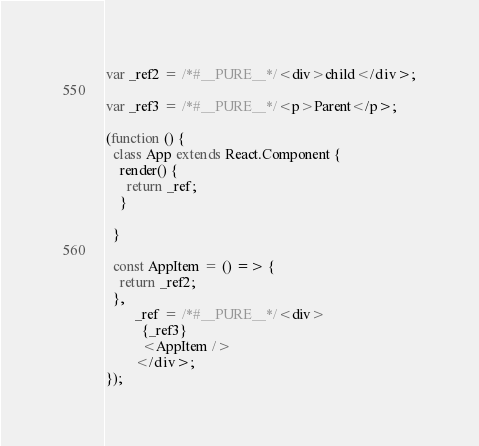Convert code to text. <code><loc_0><loc_0><loc_500><loc_500><_JavaScript_>var _ref2 = /*#__PURE__*/<div>child</div>;

var _ref3 = /*#__PURE__*/<p>Parent</p>;

(function () {
  class App extends React.Component {
    render() {
      return _ref;
    }

  }

  const AppItem = () => {
    return _ref2;
  },
        _ref = /*#__PURE__*/<div>
          {_ref3}
          <AppItem />
        </div>;
});
</code> 